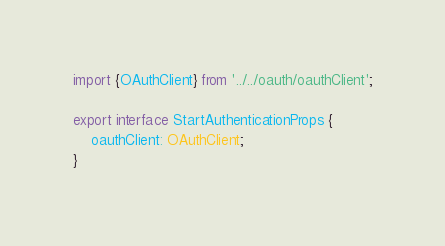<code> <loc_0><loc_0><loc_500><loc_500><_TypeScript_>import {OAuthClient} from '../../oauth/oauthClient';

export interface StartAuthenticationProps {
    oauthClient: OAuthClient;
}
</code> 